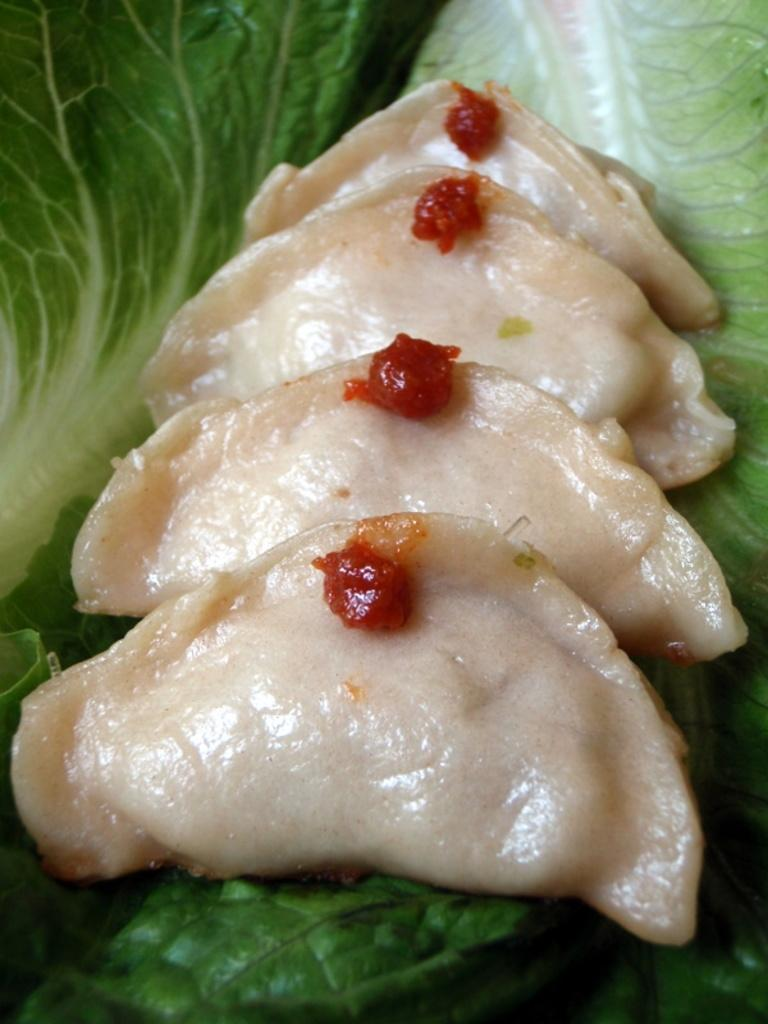What can be seen in the image? There is food in the image. What can be observed in the background of the image? There are leaves in the background of the image. What type of animals can be seen in the crate at the airport in the image? There is no crate, airport, or animals present in the image. The image only features food and leaves in the background. 